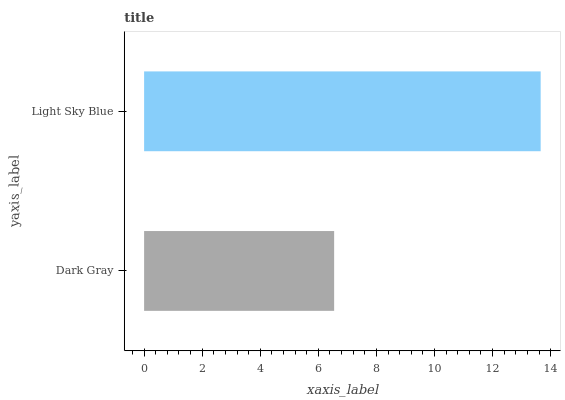Is Dark Gray the minimum?
Answer yes or no. Yes. Is Light Sky Blue the maximum?
Answer yes or no. Yes. Is Light Sky Blue the minimum?
Answer yes or no. No. Is Light Sky Blue greater than Dark Gray?
Answer yes or no. Yes. Is Dark Gray less than Light Sky Blue?
Answer yes or no. Yes. Is Dark Gray greater than Light Sky Blue?
Answer yes or no. No. Is Light Sky Blue less than Dark Gray?
Answer yes or no. No. Is Light Sky Blue the high median?
Answer yes or no. Yes. Is Dark Gray the low median?
Answer yes or no. Yes. Is Dark Gray the high median?
Answer yes or no. No. Is Light Sky Blue the low median?
Answer yes or no. No. 